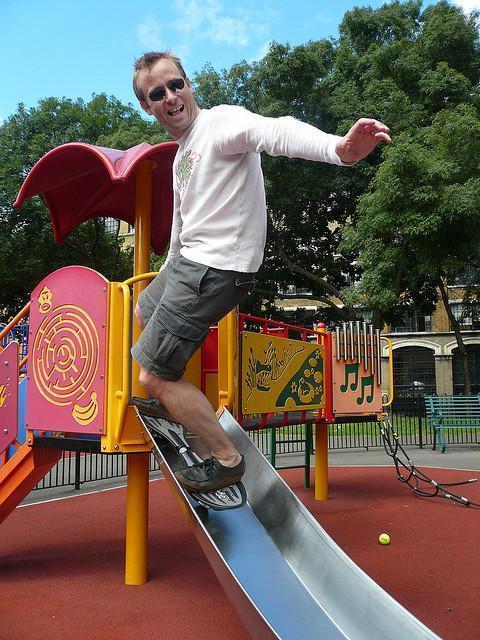The feet of the man are placed on what two wheeled object?
Choose the right answer from the provided options to respond to the question.
Options: Scooter, hoverboard, skateboard, caster board. Caster board. 